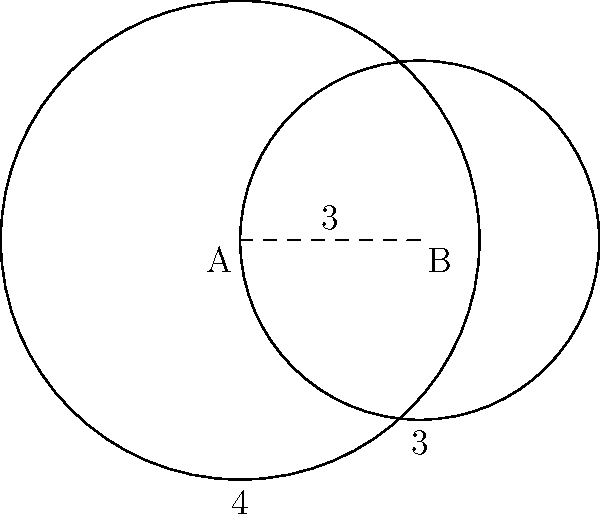Two circular patient data sets intersect as shown in the diagram. Set A has a radius of 4 units, and set B has a radius of 3 units. The centers of the circles are 3 units apart. Calculate the area of overlap between the two data sets, representing shared patient information. Round your answer to two decimal places. To find the area of overlap between two intersecting circles, we'll use the following steps:

1) First, we need to find the central angle for each circle. Let's call these angles $\theta_A$ and $\theta_B$.

2) We can find these angles using the cosine law:

   For circle A: $\cos(\frac{\theta_A}{2}) = \frac{3^2 + 4^2 - 3^2}{2 \cdot 3 \cdot 4} = \frac{7}{24}$
   For circle B: $\cos(\frac{\theta_B}{2}) = \frac{3^2 + 3^2 - 4^2}{2 \cdot 3 \cdot 3} = \frac{1}{6}$

3) Taking the inverse cosine:
   $\theta_A = 2 \cdot \arccos(\frac{7}{24}) \approx 2.498$ radians
   $\theta_B = 2 \cdot \arccos(\frac{1}{6}) \approx 2.819$ radians

4) The area of overlap is the sum of two circular sectors minus the area of the rhombus formed by the radii:

   Area = $\frac{1}{2}r_A^2\theta_A + \frac{1}{2}r_B^2\theta_B - (r_A^2\sin(\frac{\theta_A}{2}) + r_B^2\sin(\frac{\theta_B}{2}))$

5) Plugging in the values:
   Area = $\frac{1}{2}(4^2 \cdot 2.498 + 3^2 \cdot 2.819) - (4^2\sin(1.249) + 3^2\sin(1.4095))$
        $\approx 19.984 - 11.373$
        $\approx 8.611$ square units

6) Rounding to two decimal places: 8.61 square units.
Answer: 8.61 square units 